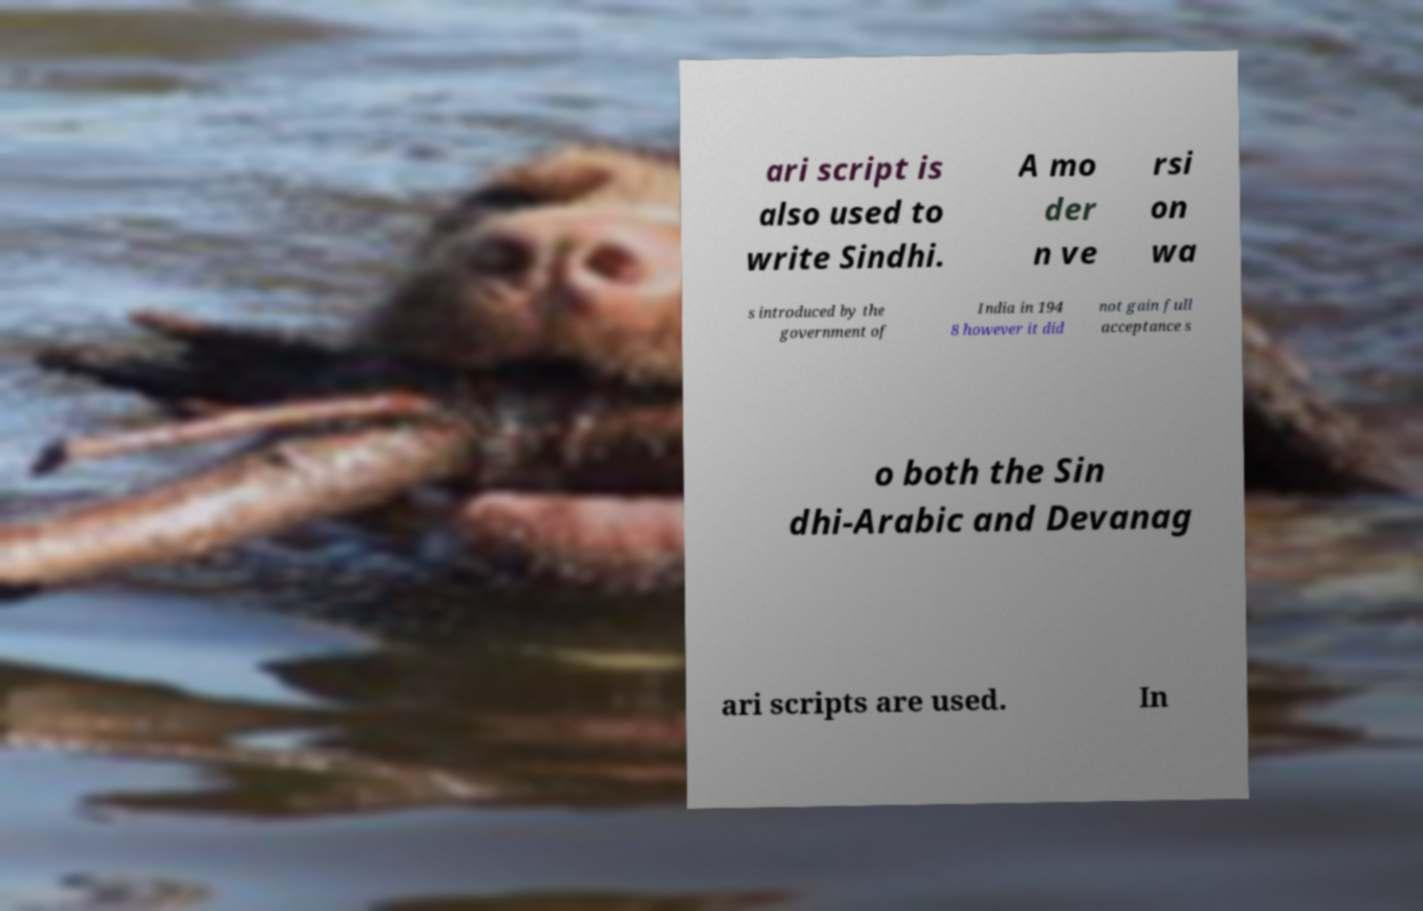Could you assist in decoding the text presented in this image and type it out clearly? ari script is also used to write Sindhi. A mo der n ve rsi on wa s introduced by the government of India in 194 8 however it did not gain full acceptance s o both the Sin dhi-Arabic and Devanag ari scripts are used. In 